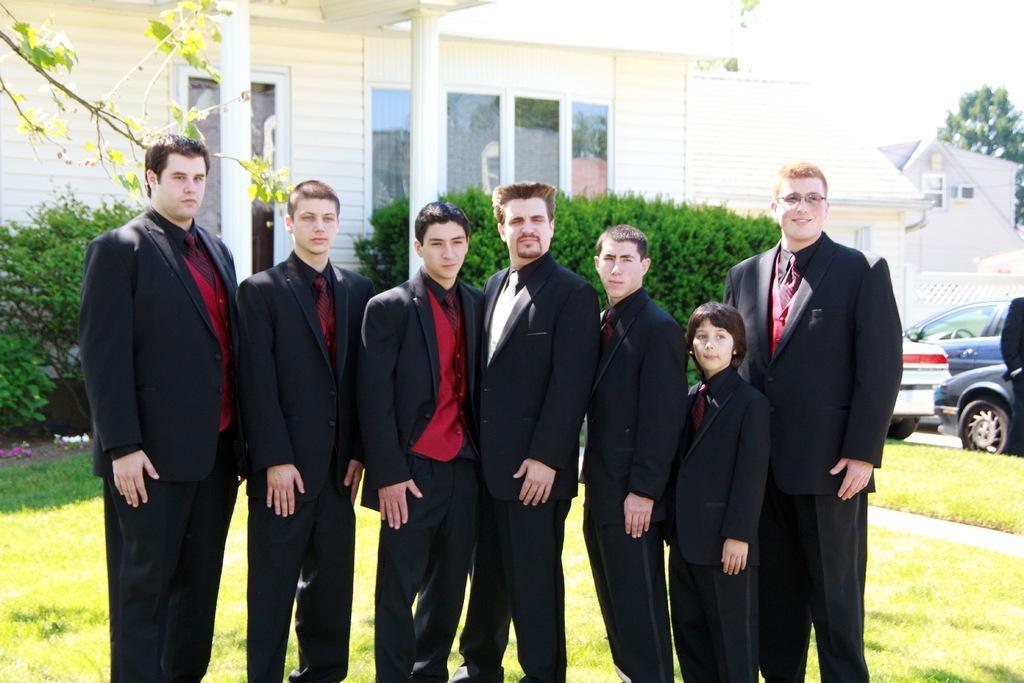Can you describe this image briefly? In the foreground, I can see a group of people are standing on grass. In the background, I can see vehicles, houseplants, trees, buildings, windows, fence and the sky. This picture might be taken during a day. 